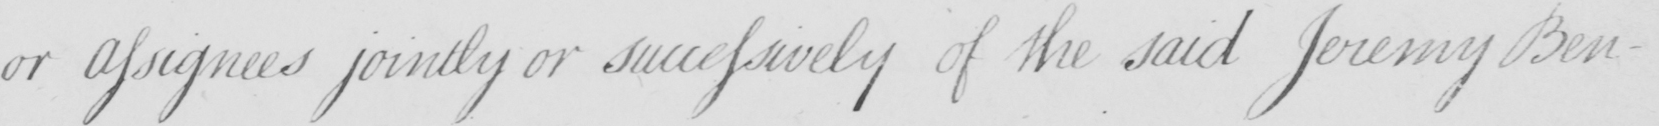Can you read and transcribe this handwriting? or Assignees jointly or successively of the said Jeremy Ben- 